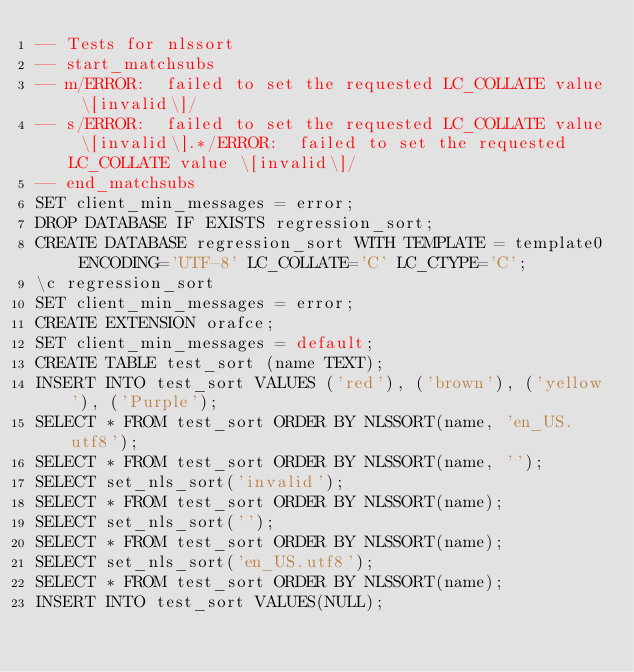<code> <loc_0><loc_0><loc_500><loc_500><_SQL_>-- Tests for nlssort
-- start_matchsubs
-- m/ERROR:  failed to set the requested LC_COLLATE value \[invalid\]/
-- s/ERROR:  failed to set the requested LC_COLLATE value \[invalid\].*/ERROR:  failed to set the requested LC_COLLATE value \[invalid\]/
-- end_matchsubs
SET client_min_messages = error;
DROP DATABASE IF EXISTS regression_sort;
CREATE DATABASE regression_sort WITH TEMPLATE = template0 ENCODING='UTF-8' LC_COLLATE='C' LC_CTYPE='C';
\c regression_sort
SET client_min_messages = error;
CREATE EXTENSION orafce;
SET client_min_messages = default;
CREATE TABLE test_sort (name TEXT);
INSERT INTO test_sort VALUES ('red'), ('brown'), ('yellow'), ('Purple');
SELECT * FROM test_sort ORDER BY NLSSORT(name, 'en_US.utf8');
SELECT * FROM test_sort ORDER BY NLSSORT(name, '');
SELECT set_nls_sort('invalid');
SELECT * FROM test_sort ORDER BY NLSSORT(name);
SELECT set_nls_sort('');
SELECT * FROM test_sort ORDER BY NLSSORT(name);
SELECT set_nls_sort('en_US.utf8');
SELECT * FROM test_sort ORDER BY NLSSORT(name);
INSERT INTO test_sort VALUES(NULL);</code> 